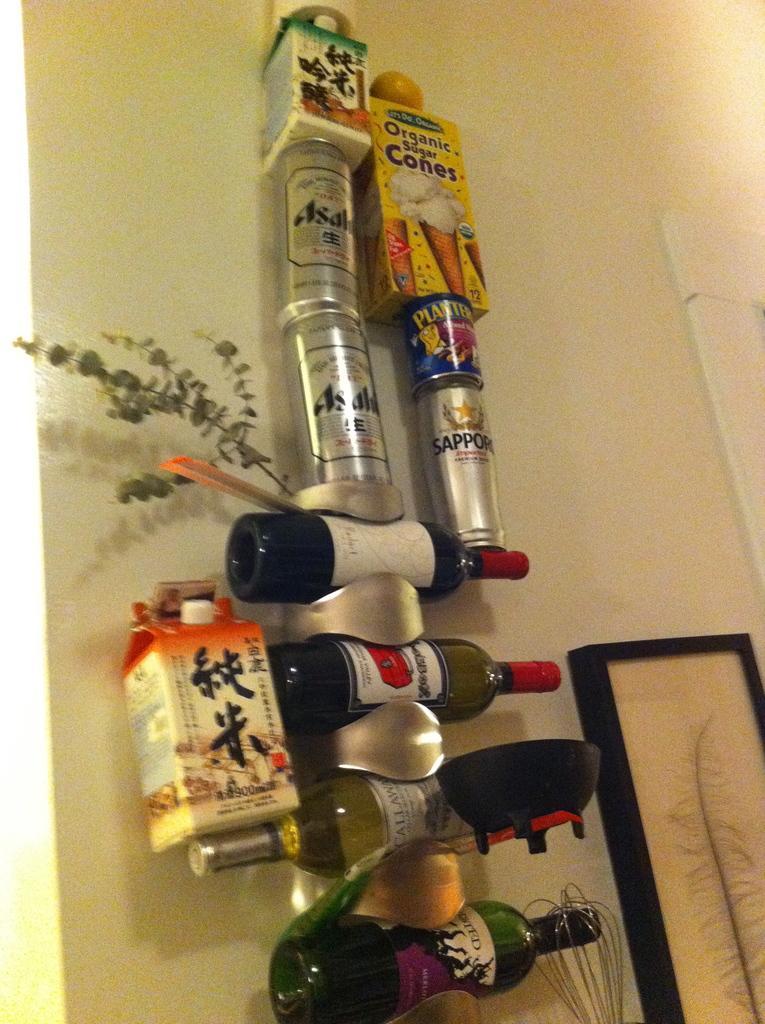How would you summarize this image in a sentence or two? In this image,, there are few bottles and tins are hanging. On the bottom, we can see whisk and photo frame and wall at the back side. 